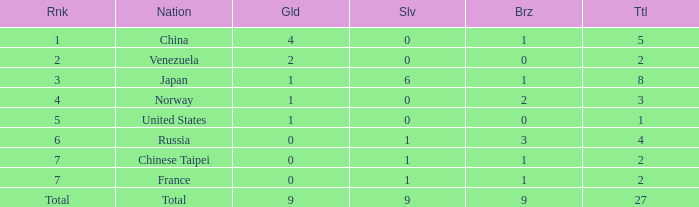What is the total number of Bronze when gold is more than 1 and nation is total? 1.0. 